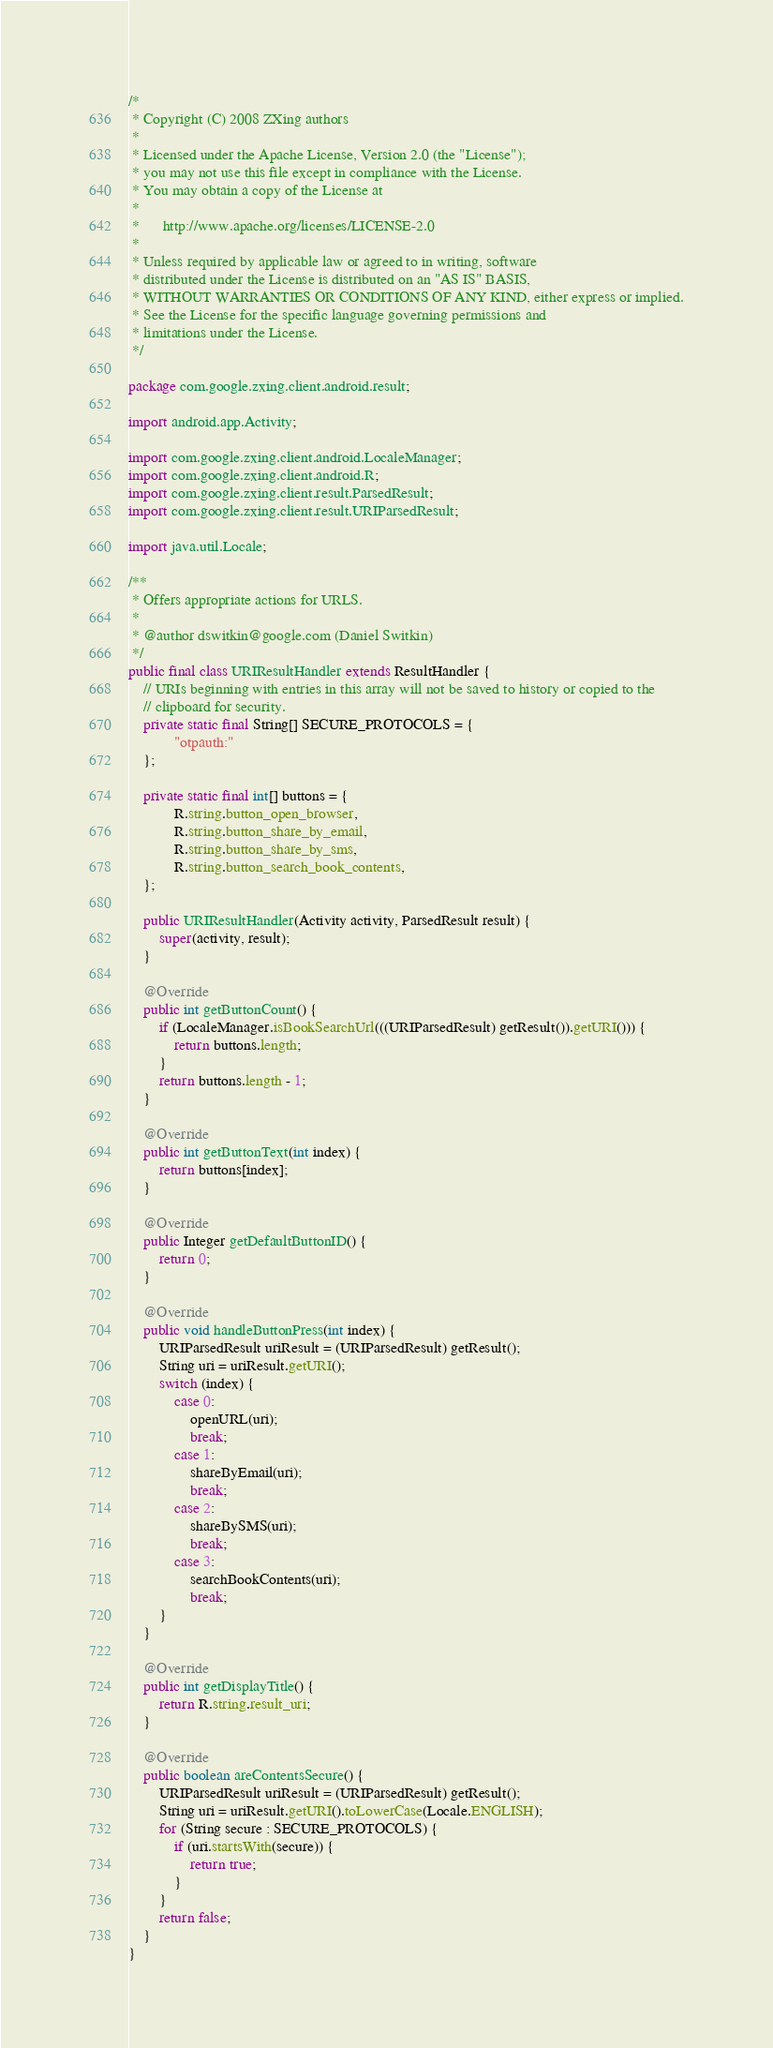Convert code to text. <code><loc_0><loc_0><loc_500><loc_500><_Java_>/*
 * Copyright (C) 2008 ZXing authors
 *
 * Licensed under the Apache License, Version 2.0 (the "License");
 * you may not use this file except in compliance with the License.
 * You may obtain a copy of the License at
 *
 *      http://www.apache.org/licenses/LICENSE-2.0
 *
 * Unless required by applicable law or agreed to in writing, software
 * distributed under the License is distributed on an "AS IS" BASIS,
 * WITHOUT WARRANTIES OR CONDITIONS OF ANY KIND, either express or implied.
 * See the License for the specific language governing permissions and
 * limitations under the License.
 */

package com.google.zxing.client.android.result;

import android.app.Activity;

import com.google.zxing.client.android.LocaleManager;
import com.google.zxing.client.android.R;
import com.google.zxing.client.result.ParsedResult;
import com.google.zxing.client.result.URIParsedResult;

import java.util.Locale;

/**
 * Offers appropriate actions for URLS.
 *
 * @author dswitkin@google.com (Daniel Switkin)
 */
public final class URIResultHandler extends ResultHandler {
    // URIs beginning with entries in this array will not be saved to history or copied to the
    // clipboard for security.
    private static final String[] SECURE_PROTOCOLS = {
            "otpauth:"
    };

    private static final int[] buttons = {
            R.string.button_open_browser,
            R.string.button_share_by_email,
            R.string.button_share_by_sms,
            R.string.button_search_book_contents,
    };

    public URIResultHandler(Activity activity, ParsedResult result) {
        super(activity, result);
    }

    @Override
    public int getButtonCount() {
        if (LocaleManager.isBookSearchUrl(((URIParsedResult) getResult()).getURI())) {
            return buttons.length;
        }
        return buttons.length - 1;
    }

    @Override
    public int getButtonText(int index) {
        return buttons[index];
    }

    @Override
    public Integer getDefaultButtonID() {
        return 0;
    }

    @Override
    public void handleButtonPress(int index) {
        URIParsedResult uriResult = (URIParsedResult) getResult();
        String uri = uriResult.getURI();
        switch (index) {
            case 0:
                openURL(uri);
                break;
            case 1:
                shareByEmail(uri);
                break;
            case 2:
                shareBySMS(uri);
                break;
            case 3:
                searchBookContents(uri);
                break;
        }
    }

    @Override
    public int getDisplayTitle() {
        return R.string.result_uri;
    }

    @Override
    public boolean areContentsSecure() {
        URIParsedResult uriResult = (URIParsedResult) getResult();
        String uri = uriResult.getURI().toLowerCase(Locale.ENGLISH);
        for (String secure : SECURE_PROTOCOLS) {
            if (uri.startsWith(secure)) {
                return true;
            }
        }
        return false;
    }
}
</code> 